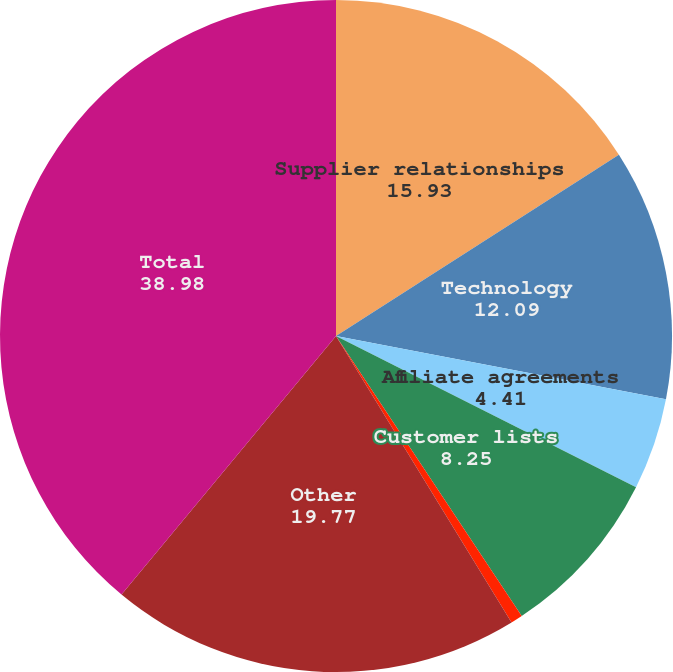Convert chart to OTSL. <chart><loc_0><loc_0><loc_500><loc_500><pie_chart><fcel>Supplier relationships<fcel>Technology<fcel>Affiliate agreements<fcel>Customer lists<fcel>Domain names<fcel>Other<fcel>Total<nl><fcel>15.93%<fcel>12.09%<fcel>4.41%<fcel>8.25%<fcel>0.57%<fcel>19.77%<fcel>38.98%<nl></chart> 